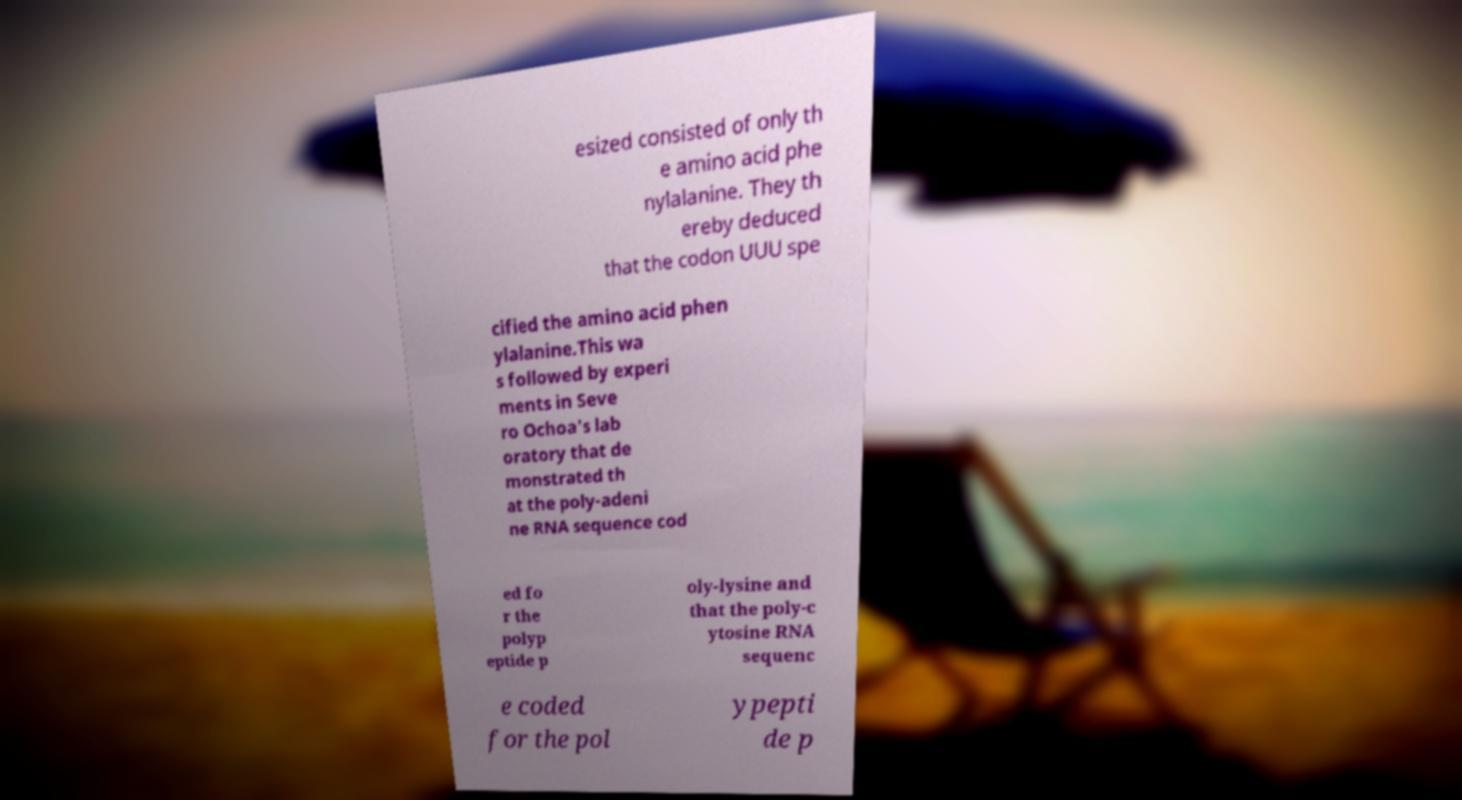Could you assist in decoding the text presented in this image and type it out clearly? esized consisted of only th e amino acid phe nylalanine. They th ereby deduced that the codon UUU spe cified the amino acid phen ylalanine.This wa s followed by experi ments in Seve ro Ochoa's lab oratory that de monstrated th at the poly-adeni ne RNA sequence cod ed fo r the polyp eptide p oly-lysine and that the poly-c ytosine RNA sequenc e coded for the pol ypepti de p 